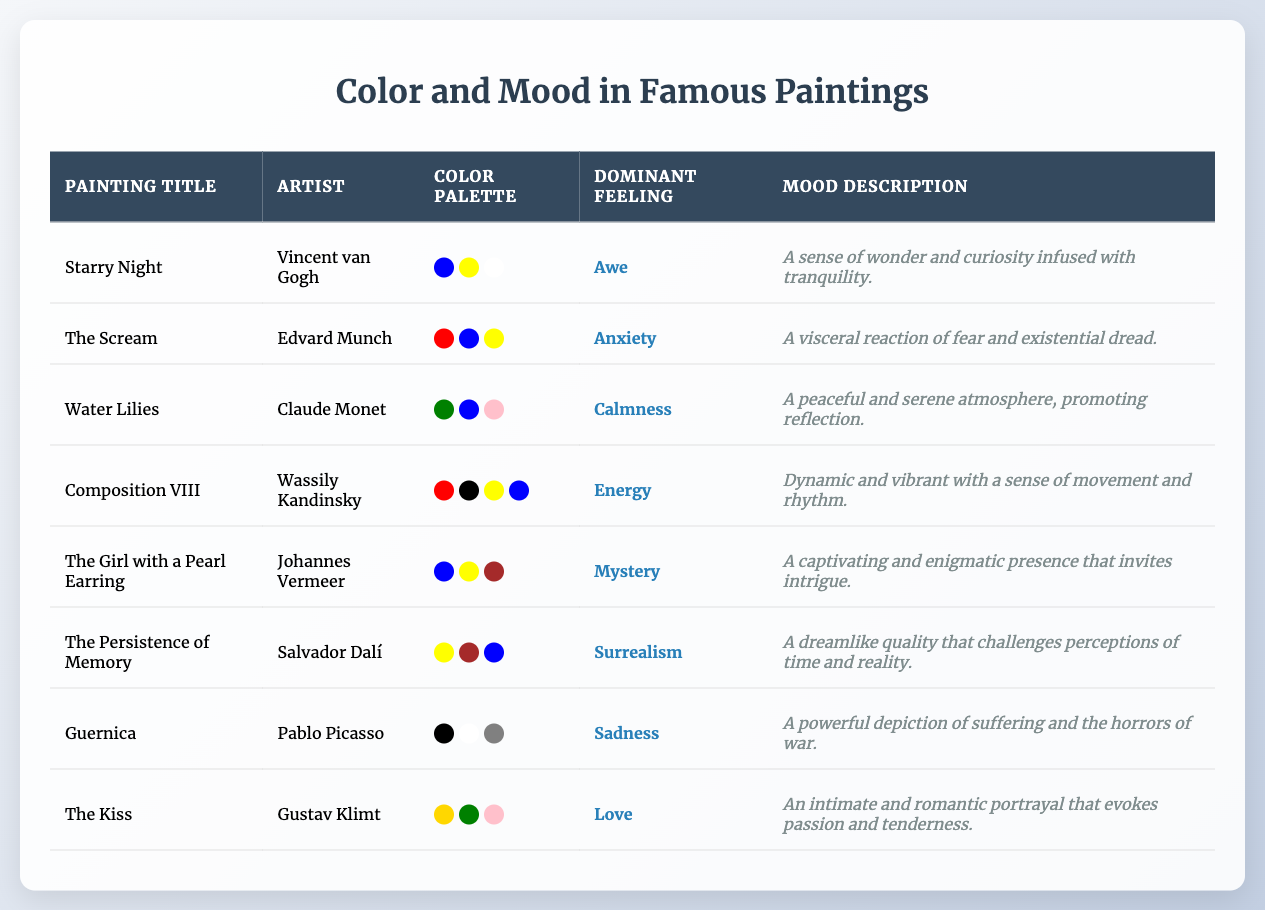What is the dominant feeling associated with "Water Lilies"? The table lists "Water Lilies" and shows that its dominant feeling is "Calmness." This is clearly stated in the table under the "Dominant Feeling" column.
Answer: Calmness Which painting has a color palette that includes gold? By examining the "Color Palette" column in the table, we can see that "The Kiss" has a color palette that includes gold as one of its colors. This is the only painting in the list with this specific color.
Answer: The Kiss What mood description is associated with "The Persistence of Memory"? The table provides a mood description for "The Persistence of Memory," which is "A dreamlike quality that challenges perceptions of time and reality." This specific description can be found in the "Mood Description" column next to the painting title.
Answer: A dreamlike quality that challenges perceptions of time and reality Are there any paintings that evoke feelings of sadness? The table indicates that "Guernica" has a dominant feeling of "Sadness." The presence of at least one painting associated with that emotion confirms that the answer is yes.
Answer: Yes How many different colors are included in the color palette for "Composition VIII"? From the "Color Palette" column for "Composition VIII," we see that it includes four colors: Red, Black, Yellow, and Blue. Therefore, the total number of different colors in its palette is four.
Answer: 4 Which painting has the most complex emotional experience based on a varied color palette? Examining the table, "Composition VIII" has four colors in its palette and a dominant feeling of "Energy," suggesting a dynamic and vibrant emotional experience compared to others with fewer colors. This complexity makes it stand out.
Answer: Composition VIII Do any paintings utilize blue in their color palette that are also associated with feelings of love or calmness? Referring to the table, "Water Lilies" is associated with the feeling of calmness and uses blue in its color palette, while "The Kiss," linked to love, does not have blue. So, the only painting satisfying both criteria is "Water Lilies."
Answer: Water Lilies Which painting evokes anxiety, and what are the main colors in its palette? "The Scream" is indicated as having a dominant feeling of anxiety. The colors in its palette, as shown in the table, are Red, Blue, and Yellow, directly stated in the color section.
Answer: The Scream; Red, Blue, Yellow How does the emotional impact of the color palette for "The Kiss" compare to that of "The Scream"? "The Kiss" evokes feelings of love with colors Gold, Green, and Pink, creating an intimate mood, while "The Scream," with Red, Blue, and Yellow, evokes anxiety. The contrast indicates that the palettes influence their moods quite differently, with one portraying tenderness and the other fear.
Answer: Love vs. Anxiety 